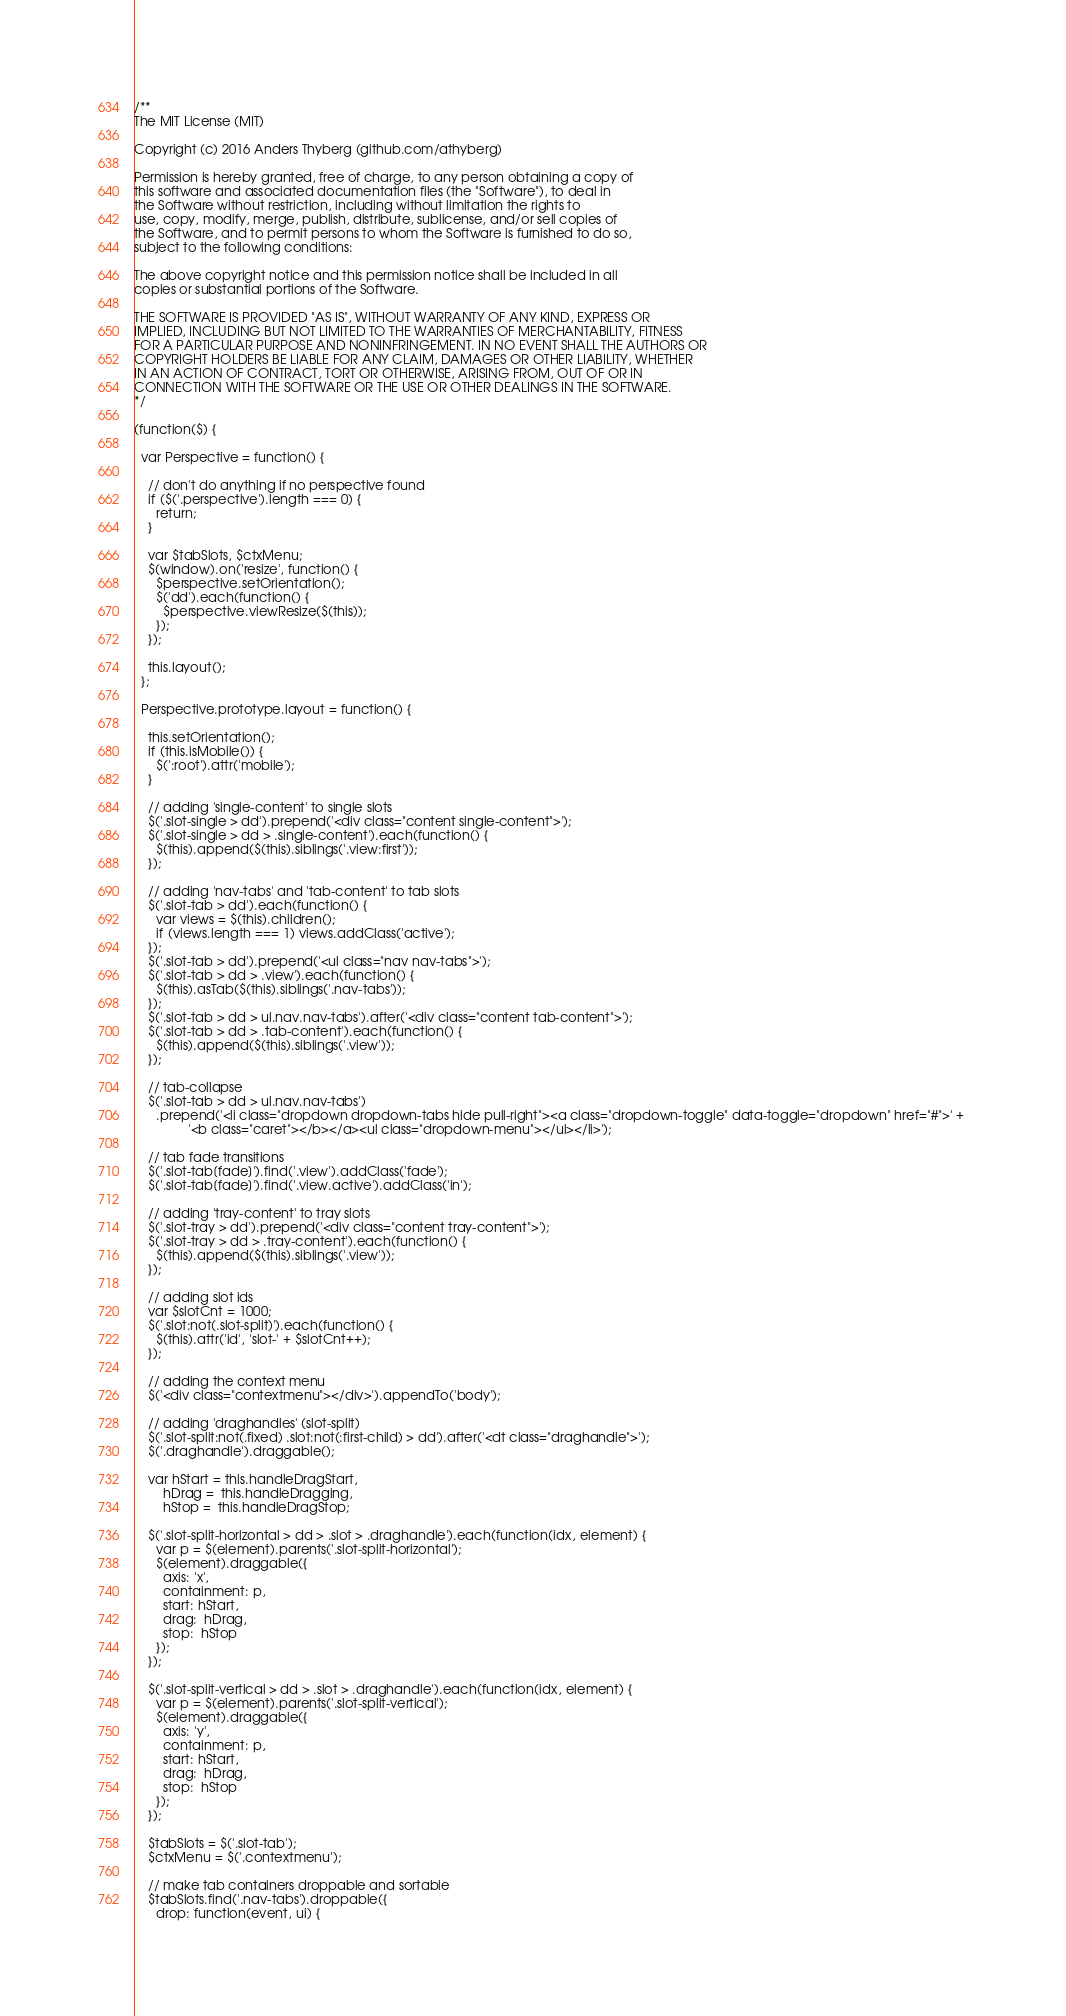<code> <loc_0><loc_0><loc_500><loc_500><_JavaScript_>/**
The MIT License (MIT)

Copyright (c) 2016 Anders Thyberg (github.com/athyberg)

Permission is hereby granted, free of charge, to any person obtaining a copy of
this software and associated documentation files (the "Software"), to deal in
the Software without restriction, including without limitation the rights to
use, copy, modify, merge, publish, distribute, sublicense, and/or sell copies of
the Software, and to permit persons to whom the Software is furnished to do so,
subject to the following conditions:

The above copyright notice and this permission notice shall be included in all
copies or substantial portions of the Software.

THE SOFTWARE IS PROVIDED "AS IS", WITHOUT WARRANTY OF ANY KIND, EXPRESS OR
IMPLIED, INCLUDING BUT NOT LIMITED TO THE WARRANTIES OF MERCHANTABILITY, FITNESS
FOR A PARTICULAR PURPOSE AND NONINFRINGEMENT. IN NO EVENT SHALL THE AUTHORS OR
COPYRIGHT HOLDERS BE LIABLE FOR ANY CLAIM, DAMAGES OR OTHER LIABILITY, WHETHER
IN AN ACTION OF CONTRACT, TORT OR OTHERWISE, ARISING FROM, OUT OF OR IN
CONNECTION WITH THE SOFTWARE OR THE USE OR OTHER DEALINGS IN THE SOFTWARE.
*/

(function($) {

  var Perspective = function() {

    // don't do anything if no perspective found 
    if ($('.perspective').length === 0) {
      return;
    } 

    var $tabSlots, $ctxMenu;
    $(window).on('resize', function() {
      $perspective.setOrientation();
      $('dd').each(function() {
        $perspective.viewResize($(this));
      });        
    });

    this.layout();
  };

  Perspective.prototype.layout = function() {

    this.setOrientation();
    if (this.isMobile()) {
      $(':root').attr('mobile');
    }

    // adding 'single-content' to single slots
    $('.slot-single > dd').prepend('<div class="content single-content">');
    $('.slot-single > dd > .single-content').each(function() {
      $(this).append($(this).siblings('.view:first'));
    });
    
    // adding 'nav-tabs' and 'tab-content' to tab slots
    $('.slot-tab > dd').each(function() {
      var views = $(this).children();
      if (views.length === 1) views.addClass('active');
    }); 
    $('.slot-tab > dd').prepend('<ul class="nav nav-tabs">');
    $('.slot-tab > dd > .view').each(function() {
      $(this).asTab($(this).siblings('.nav-tabs'));
    });
    $('.slot-tab > dd > ul.nav.nav-tabs').after('<div class="content tab-content">');
    $('.slot-tab > dd > .tab-content').each(function() {
      $(this).append($(this).siblings('.view'));
    });

    // tab-collapse
    $('.slot-tab > dd > ul.nav.nav-tabs')
      .prepend('<li class="dropdown dropdown-tabs hide pull-right"><a class="dropdown-toggle" data-toggle="dropdown" href="#">' + 
               '<b class="caret"></b></a><ul class="dropdown-menu"></ul></li>');

    // tab fade transitions
    $('.slot-tab[fade]').find('.view').addClass('fade');
    $('.slot-tab[fade]').find('.view.active').addClass('in');

    // adding 'tray-content' to tray slots
    $('.slot-tray > dd').prepend('<div class="content tray-content">');
    $('.slot-tray > dd > .tray-content').each(function() {
      $(this).append($(this).siblings('.view'));
    });

    // adding slot ids
    var $slotCnt = 1000;
    $('.slot:not(.slot-split)').each(function() {
      $(this).attr('id', 'slot-' + $slotCnt++);
    });

    // adding the context menu
    $('<div class="contextmenu"></div>').appendTo('body');

    // adding 'draghandles' (slot-split)
    $('.slot-split:not(.fixed) .slot:not(:first-child) > dd').after('<dt class="draghandle">');
    $('.draghandle').draggable();

    var hStart = this.handleDragStart, 
        hDrag =  this.handleDragging, 
        hStop =  this.handleDragStop;

    $('.slot-split-horizontal > dd > .slot > .draghandle').each(function(idx, element) {
      var p = $(element).parents('.slot-split-horizontal');
      $(element).draggable({
        axis: 'x',
        containment: p,
        start: hStart,
        drag:  hDrag,
        stop:  hStop
      });
    });

    $('.slot-split-vertical > dd > .slot > .draghandle').each(function(idx, element) {
      var p = $(element).parents('.slot-split-vertical');
      $(element).draggable({
        axis: 'y',
        containment: p,
        start: hStart,
        drag:  hDrag,
        stop:  hStop
      });
    });

    $tabSlots = $('.slot-tab');
    $ctxMenu = $('.contextmenu');

    // make tab containers droppable and sortable
    $tabSlots.find('.nav-tabs').droppable({
      drop: function(event, ui) {</code> 